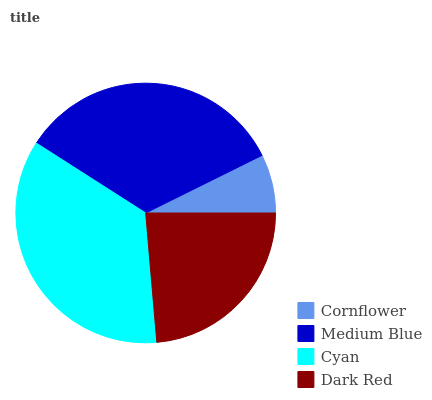Is Cornflower the minimum?
Answer yes or no. Yes. Is Cyan the maximum?
Answer yes or no. Yes. Is Medium Blue the minimum?
Answer yes or no. No. Is Medium Blue the maximum?
Answer yes or no. No. Is Medium Blue greater than Cornflower?
Answer yes or no. Yes. Is Cornflower less than Medium Blue?
Answer yes or no. Yes. Is Cornflower greater than Medium Blue?
Answer yes or no. No. Is Medium Blue less than Cornflower?
Answer yes or no. No. Is Medium Blue the high median?
Answer yes or no. Yes. Is Dark Red the low median?
Answer yes or no. Yes. Is Cyan the high median?
Answer yes or no. No. Is Cornflower the low median?
Answer yes or no. No. 